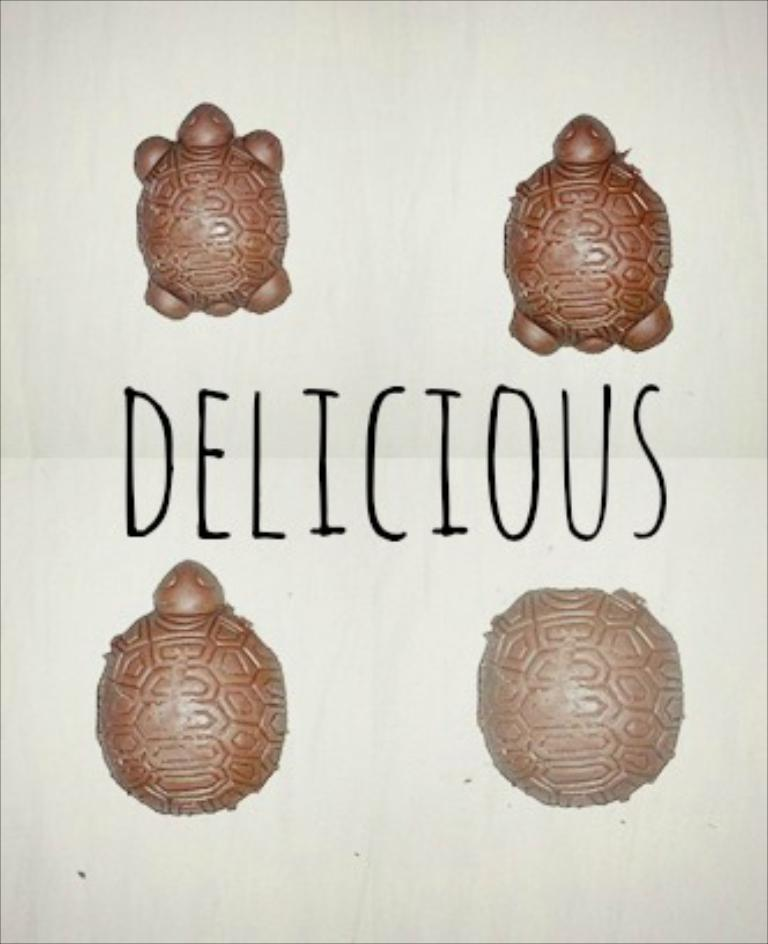What types of animals are present in the image? There are different types of tortoises in the image. Can you describe the tortoises in the image? The image shows various tortoises, but specific details about their appearance or characteristics are not provided. What type of truck can be seen in the image? There is no truck present in the image; it features different types of tortoises. How many times do the tortoises shake hands in the image? Tortoises do not have the ability to shake hands, and there is no indication of such an action in the image. 